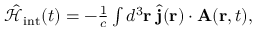Convert formula to latex. <formula><loc_0><loc_0><loc_500><loc_500>\begin{array} { r } { \hat { \mathcal { H } } _ { i n t } ( t ) = - \frac { 1 } { c } \int d ^ { 3 } { r } \, \hat { j } ( { r } ) \cdot { A } ( { r } , t ) , } \end{array}</formula> 